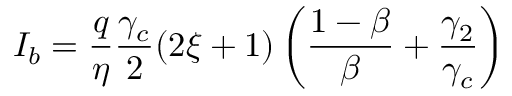<formula> <loc_0><loc_0><loc_500><loc_500>I _ { b } = \frac { q } { \eta } \frac { \gamma _ { c } } { 2 } ( 2 \xi + 1 ) \left ( \frac { 1 - \beta } { \beta } + \frac { \gamma _ { 2 } } { \gamma _ { c } } \right )</formula> 